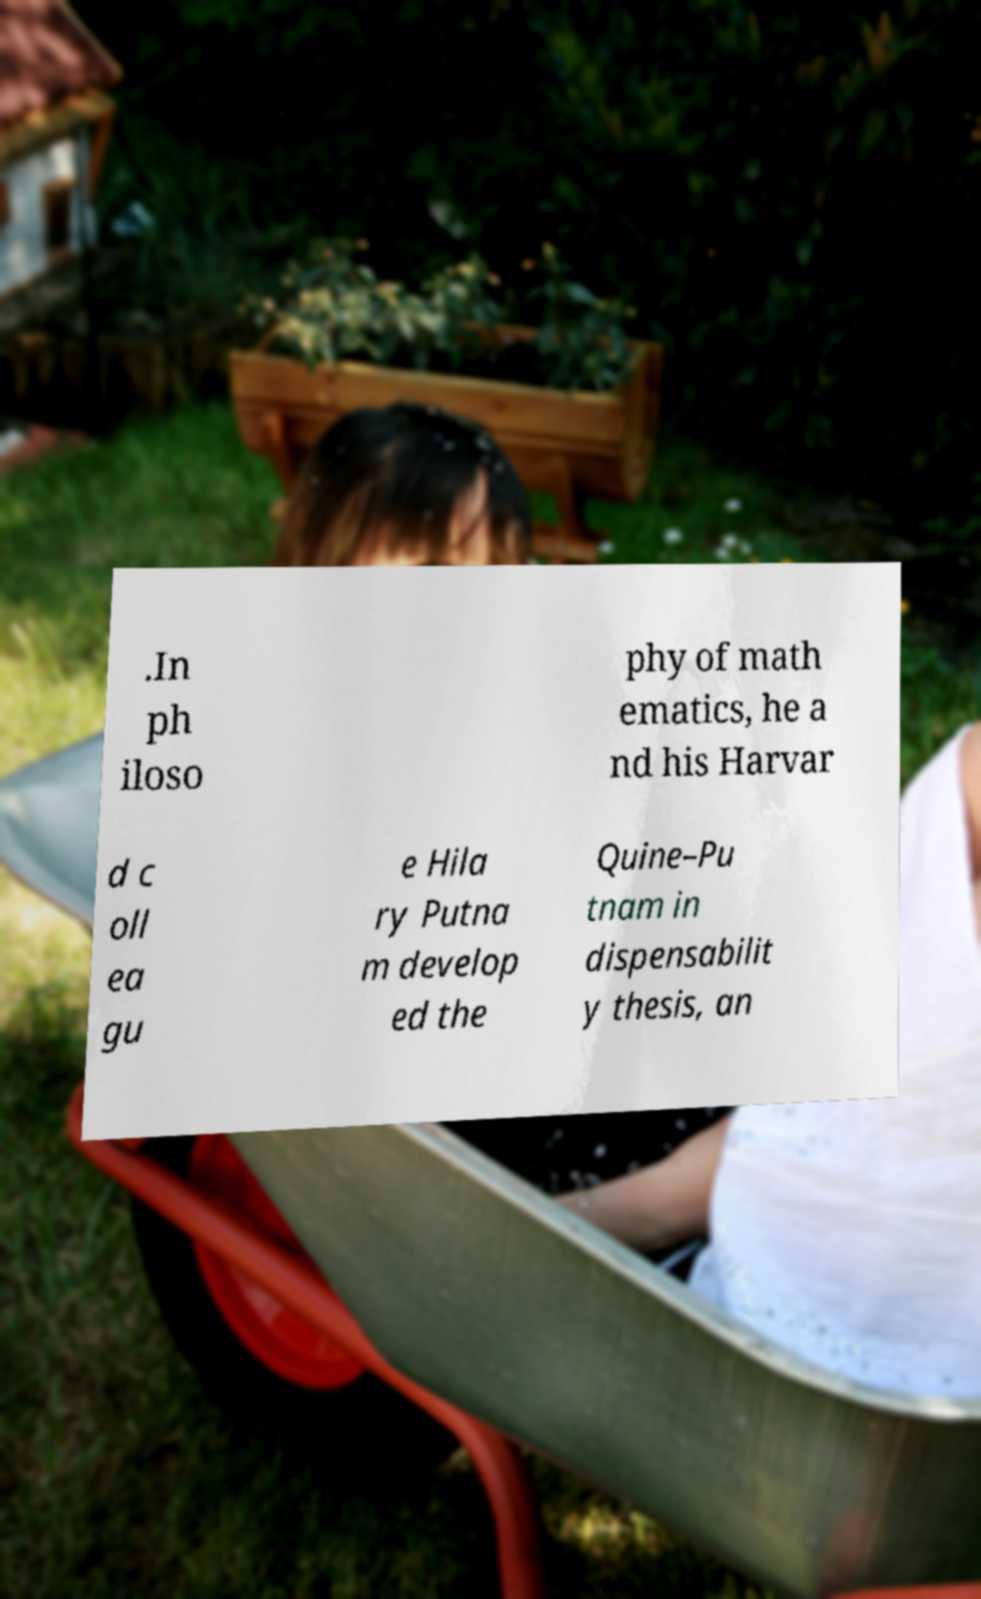For documentation purposes, I need the text within this image transcribed. Could you provide that? .In ph iloso phy of math ematics, he a nd his Harvar d c oll ea gu e Hila ry Putna m develop ed the Quine–Pu tnam in dispensabilit y thesis, an 